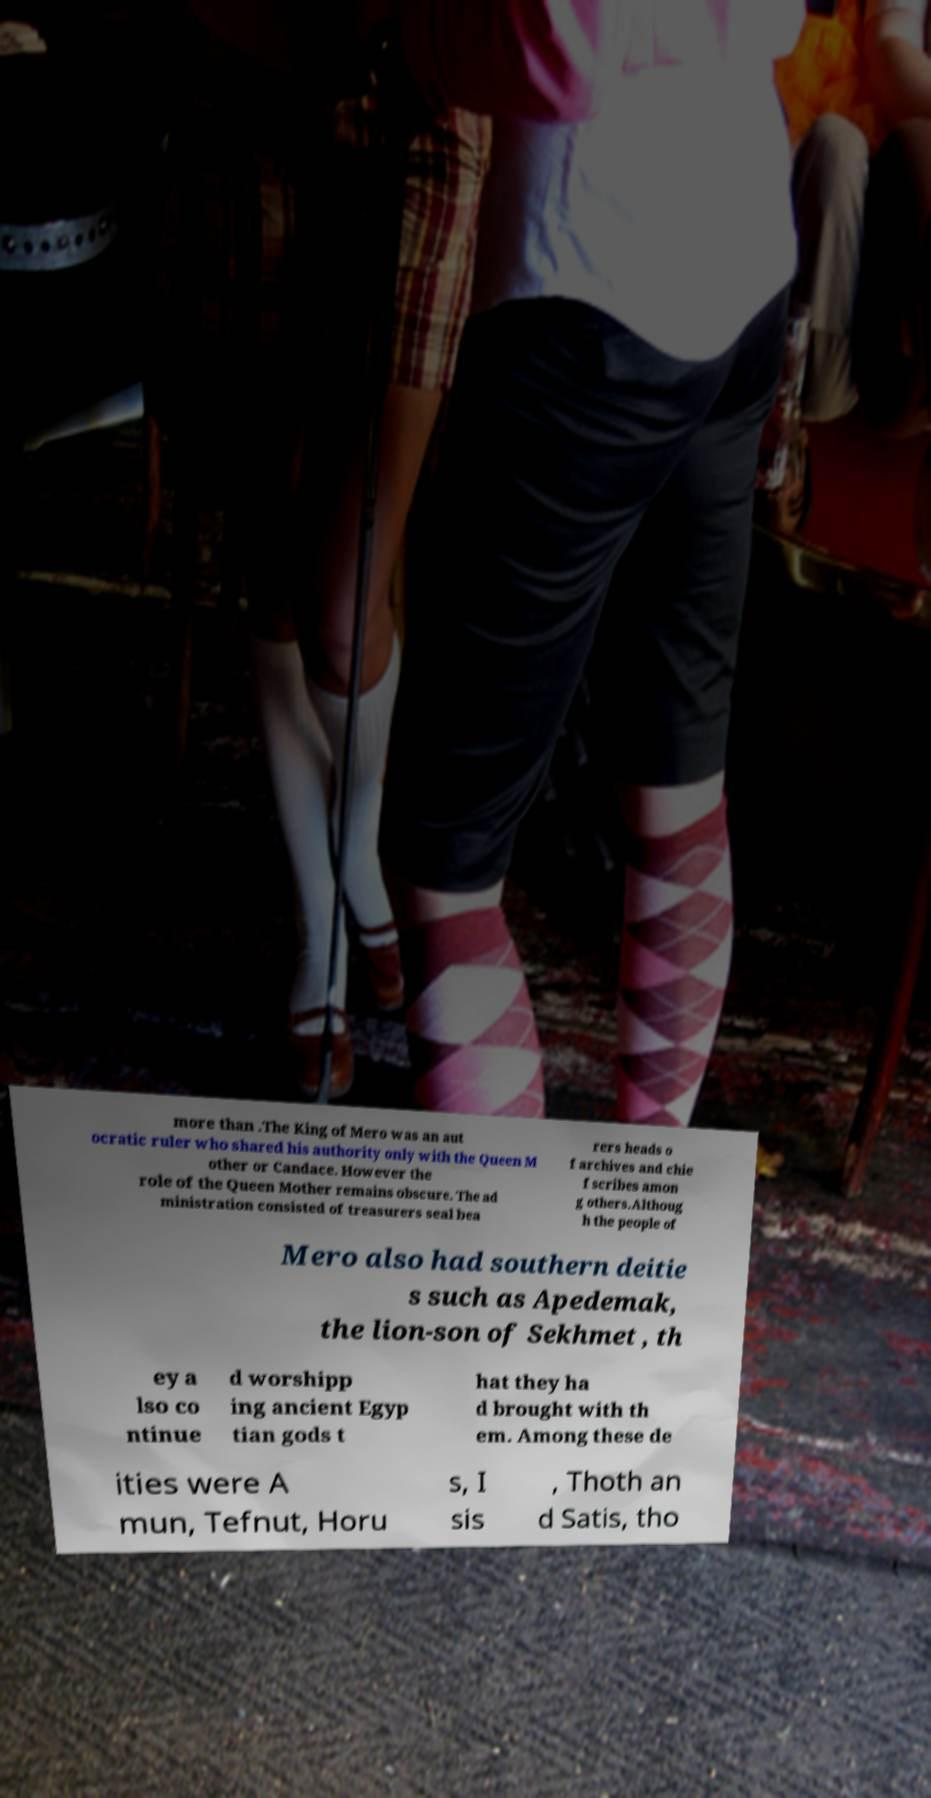Can you accurately transcribe the text from the provided image for me? more than .The King of Mero was an aut ocratic ruler who shared his authority only with the Queen M other or Candace. However the role of the Queen Mother remains obscure. The ad ministration consisted of treasurers seal bea rers heads o f archives and chie f scribes amon g others.Althoug h the people of Mero also had southern deitie s such as Apedemak, the lion-son of Sekhmet , th ey a lso co ntinue d worshipp ing ancient Egyp tian gods t hat they ha d brought with th em. Among these de ities were A mun, Tefnut, Horu s, I sis , Thoth an d Satis, tho 